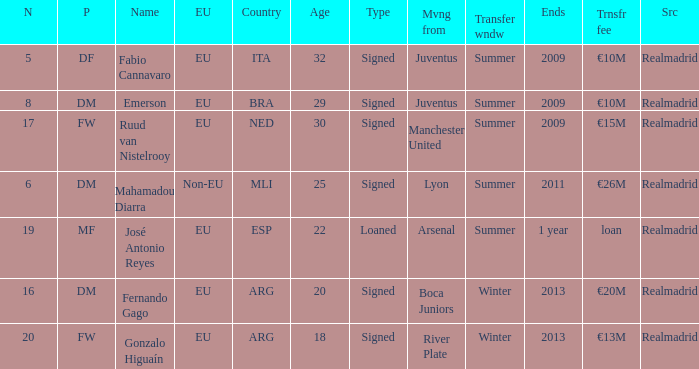What is the EU status of ESP? EU. 